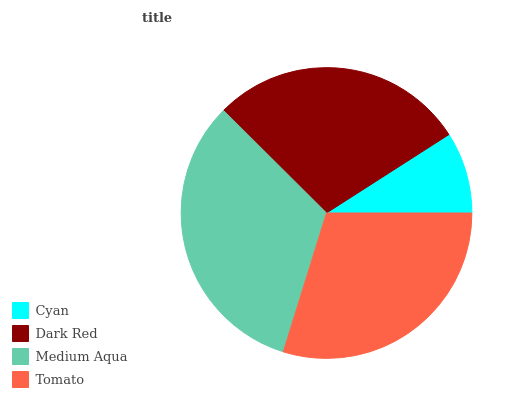Is Cyan the minimum?
Answer yes or no. Yes. Is Medium Aqua the maximum?
Answer yes or no. Yes. Is Dark Red the minimum?
Answer yes or no. No. Is Dark Red the maximum?
Answer yes or no. No. Is Dark Red greater than Cyan?
Answer yes or no. Yes. Is Cyan less than Dark Red?
Answer yes or no. Yes. Is Cyan greater than Dark Red?
Answer yes or no. No. Is Dark Red less than Cyan?
Answer yes or no. No. Is Tomato the high median?
Answer yes or no. Yes. Is Dark Red the low median?
Answer yes or no. Yes. Is Dark Red the high median?
Answer yes or no. No. Is Cyan the low median?
Answer yes or no. No. 